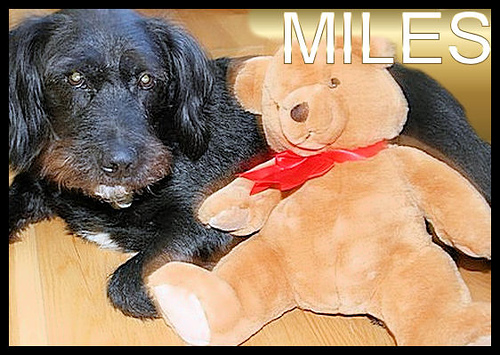Please transcribe the text in this image. MILES 